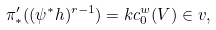Convert formula to latex. <formula><loc_0><loc_0><loc_500><loc_500>\pi ^ { \prime } _ { * } ( ( \psi ^ { * } h ) ^ { r - 1 } ) = k c _ { 0 } ^ { w } ( V ) \in v ,</formula> 